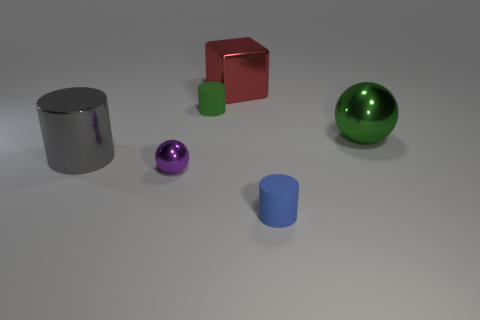How does the lighting in the scene affect the appearance of the objects? The lighting in the scene casts soft shadows beneath the objects, highlighting their three-dimensional forms. The reflective surfaces on the metal and the green rubber sphere show subtle highlights, enhancing their textures, while the matte finish of the cylinders and the cube absorbs light, giving a stark contrast between the objects. 